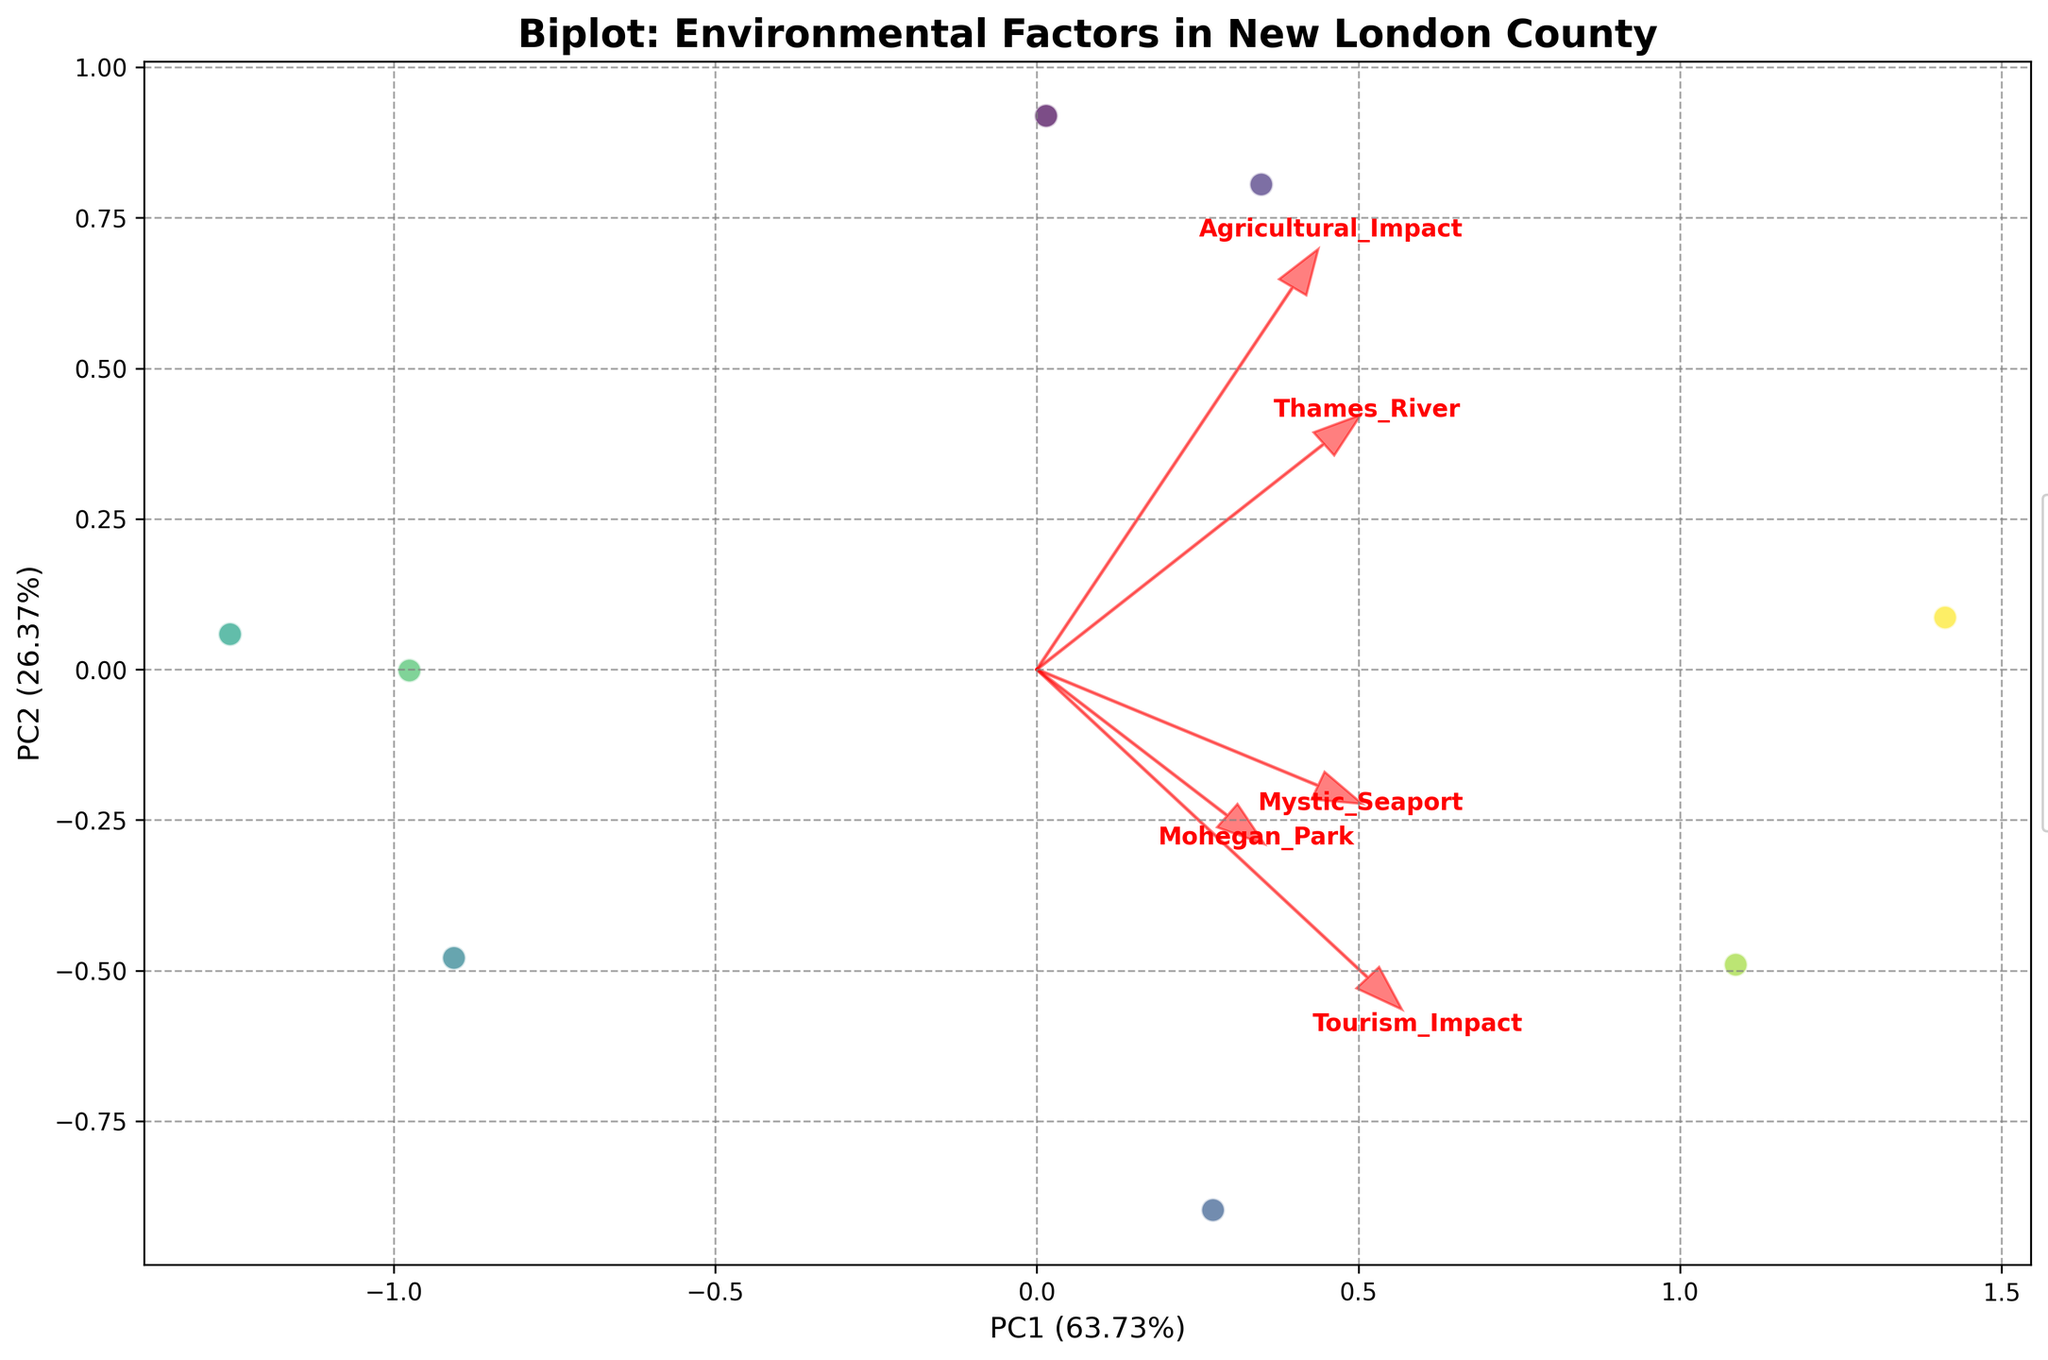What is the title of the plot? The title is usually found at the top or near the top of the plot, and it provides a brief description of the plot. In this case, it reads "Biplot: Environmental Factors in New London County."
Answer: Biplot: Environmental Factors in New London County How many environmental factors are represented in the plot? Count the different categories listed in the legend and mentioned in the text on the plot. We see categories such as Temperature Change, Precipitation Levels, etc.
Answer: 8 Which environmental factor has the highest negative impact on agricultural impact? By looking at the arrow directions corresponding to different environmental factors, the factor with the arrow pointing most strongly in a negative direction along the PC1 (x-axis) where Agricultural Impact is represented will have the highest negative impact.
Answer: Soil Erosion Which site (Thames River, Mohegan Park, or Mystic Seaport) is most positively associated with water quality? By observing the direction of the Water Quality vector and noting which site location it points towards on the plot, we determine the association.
Answer: Thames River Does Forest Cover have a positive or negative impact on tourism impact? By examining the direction of the Forest Cover vector relative to the PC2 axis (representing Tourism Impact), we see if it points positively or negatively.
Answer: Positive Which environmental factor is most closely associated with the Thames River? By checking the direction and length of the vectors, the factor vector that points closest to or directly at the spot for Thames River indicates the closest association.
Answer: Forest Cover If temperature change reduces, would it positively or negatively affect tourism in New London County? By seeing the direction that Temperature Change points relative to the Tourism Impact (PC2), we establish whether changes occurring in the opposite direction would imply the opposite impact. Here, a reduction in Temperature Change might improve tourism because of the negative starting point.
Answer: Positively Which environmental factor has the smallest effect on both agricultural and tourism impacts? Identifying the vector which is shortest or most neutral (close to the origin) in impacting both axes (PC1 for agriculture and PC2 for tourism) reveals this information.
Answer: Invasive Species Is Precipitation Levels more impactful on Thames River or Mystic Seaport? Evaluating the angle between the Precipitation Levels vector and the lines going to the sites, the one closer to the direction of the Precipitation Levels vector determines higher impact.
Answer: Thames River Which environmental factors have a positive impact on both agricultural and tourism impacts? Determine which vectors point towards positive values on both PC1 (x-axis for agriculture) and PC2 (y-axis for tourism), i.e., towards the upper-right quadrant.
Answer: Forest Cover, Water Quality 